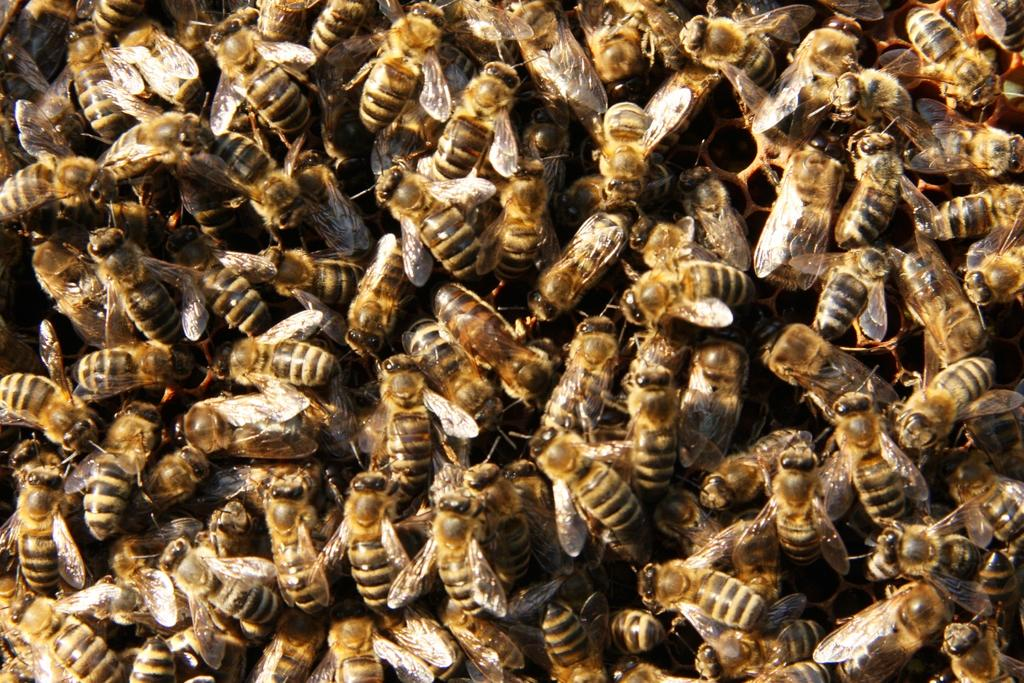What type of insects are present in the image? There is a group of honey bees in the image. Can you describe the behavior of the honey bees in the image? The provided facts do not mention the behavior of the honey bees, so we cannot describe it. What type of camera is being used to take the picture of the honey bees? The provided facts do not mention a camera, so we cannot determine the type of camera being used. Are the honey bees asking for help in the image? The provided facts do not mention the honey bees asking for help, so we cannot determine if they are asking for help. 